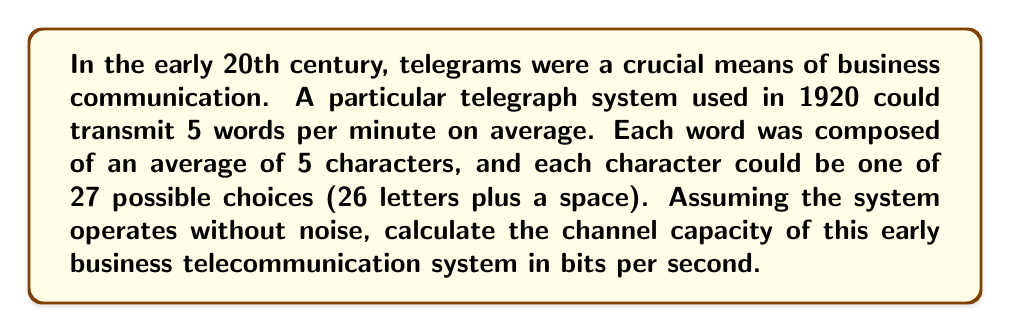Give your solution to this math problem. To solve this problem, we'll use the formula for channel capacity in a noiseless channel:

$$ C = R \log_2 M $$

Where:
$C$ is the channel capacity in bits per second
$R$ is the symbol rate (symbols per second)
$M$ is the number of possible symbols

Let's break down the problem step-by-step:

1. Calculate the symbol rate (R):
   - 5 words per minute
   - 5 characters per word
   - So, 25 characters per minute
   - Convert to characters per second: $25 / 60 = 5/12$ characters/second
   
   $R = 5/12$ symbols/second

2. Determine the number of possible symbols (M):
   $M = 27$ (26 letters plus a space)

3. Apply the channel capacity formula:

   $$ C = \frac{5}{12} \log_2 27 $$

4. Calculate $\log_2 27$:
   $$ \log_2 27 = \frac{\ln 27}{\ln 2} \approx 4.7549 $$

5. Compute the final result:
   $$ C = \frac{5}{12} \times 4.7549 \approx 1.9812 \text{ bits/second} $$

This result represents the maximum amount of information that could be transmitted through this early business telegraph system per second, assuming perfect conditions.
Answer: The channel capacity of the described early business telecommunication system is approximately 1.9812 bits per second. 